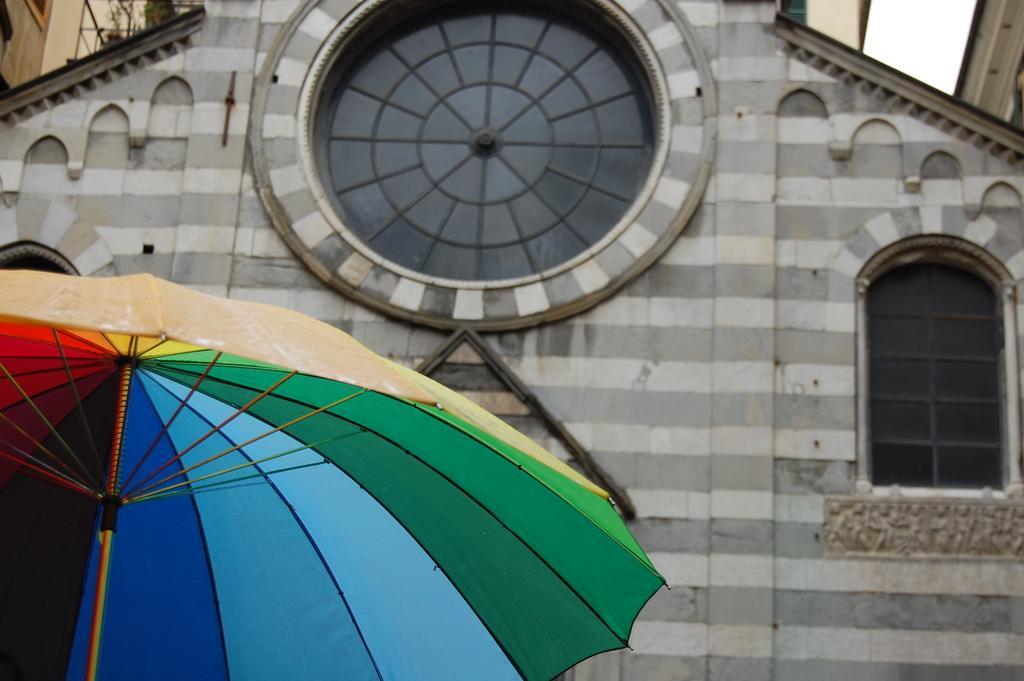Could you give a brief overview of what you see in this image? To the bottom left corner of the image there is an umbrella with different colors. Behind the umbrella there is a building with brick walls, glass windows, pillars and to the top of the image on the building there is a round shape window with the glass. 